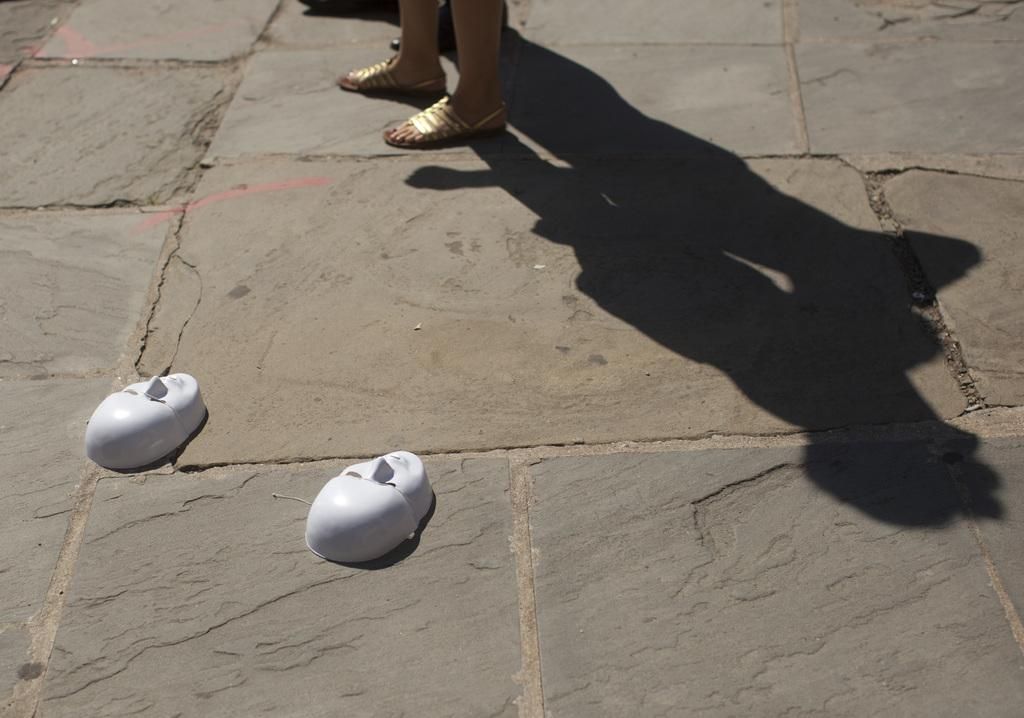What part of a person can be seen in the image? There are legs of a person in the image. What type of footwear is the person wearing? The person is wearing golden color sandals. What protective items are visible in the image? There are two white color face masks in the image. What can be observed in the image that indicates the presence of light? Shadows are visible in the image. What type of slope can be seen in the image? There is no slope present in the image. What direction is the person facing in the image? The image only shows the person's legs, so it is not possible to determine the direction they are facing. 